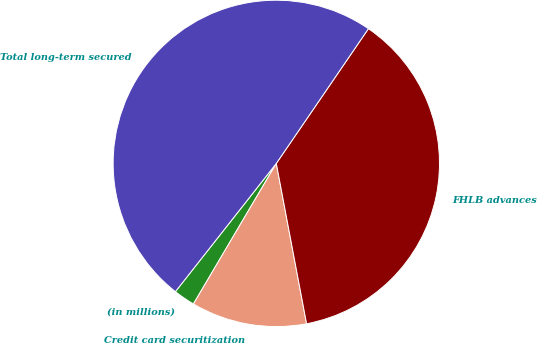Convert chart to OTSL. <chart><loc_0><loc_0><loc_500><loc_500><pie_chart><fcel>(in millions)<fcel>Credit card securitization<fcel>FHLB advances<fcel>Total long-term secured<nl><fcel>2.13%<fcel>11.45%<fcel>37.48%<fcel>48.93%<nl></chart> 